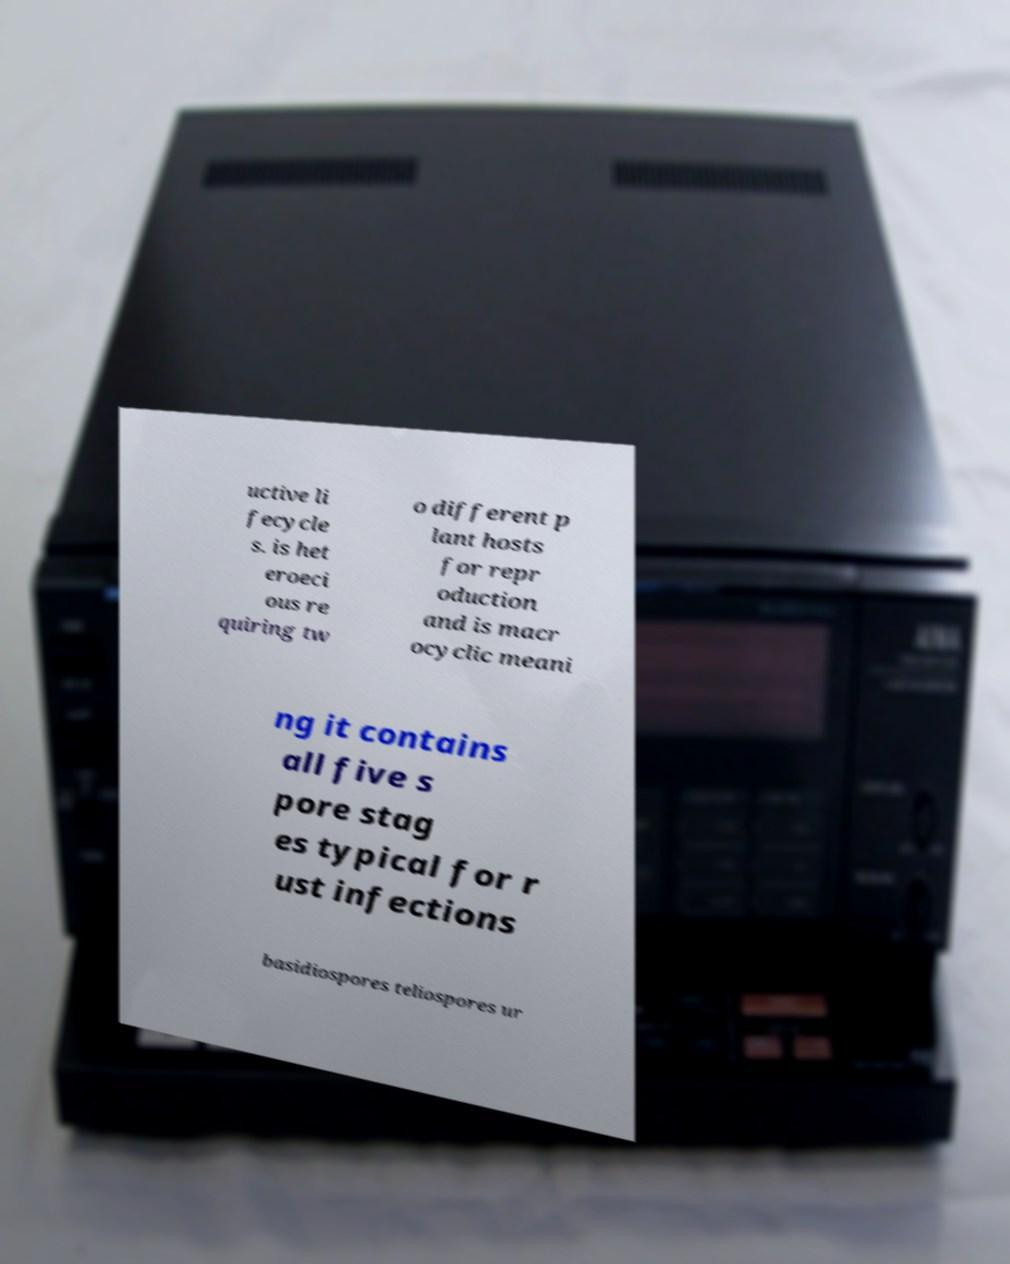Please identify and transcribe the text found in this image. uctive li fecycle s. is het eroeci ous re quiring tw o different p lant hosts for repr oduction and is macr ocyclic meani ng it contains all five s pore stag es typical for r ust infections basidiospores teliospores ur 